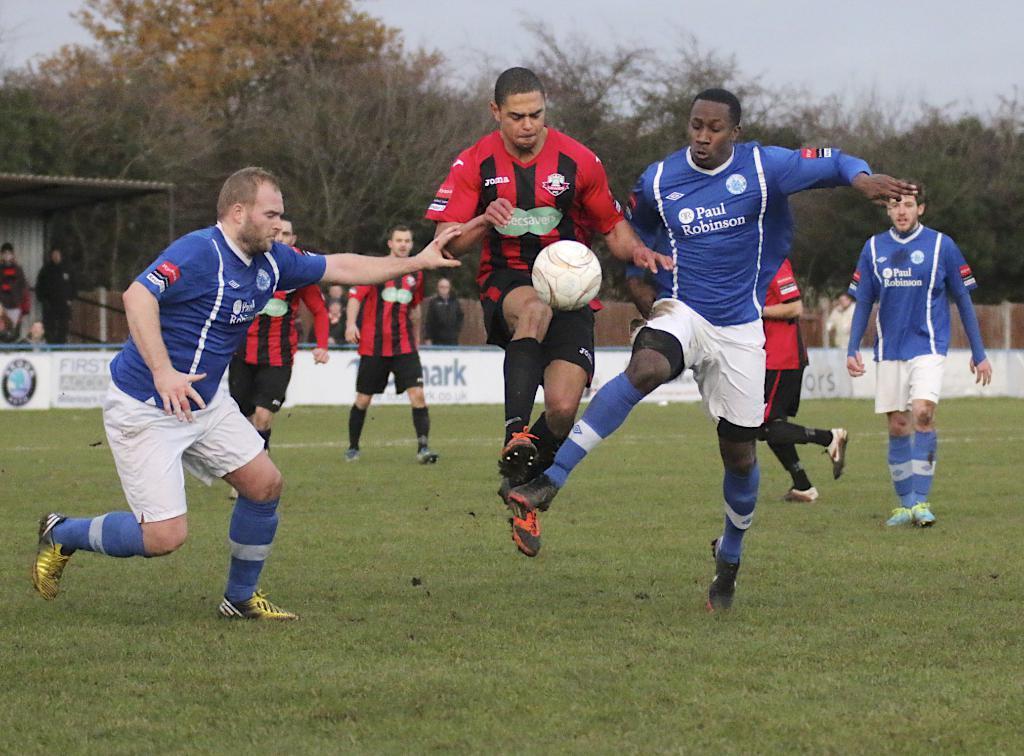Describe this image in one or two sentences. In this image we can see people playing football. In the background of the image there are trees. There is a shed. There is a banner with some text. At the bottom of the image there is grass. At the top of the image there is sky. 